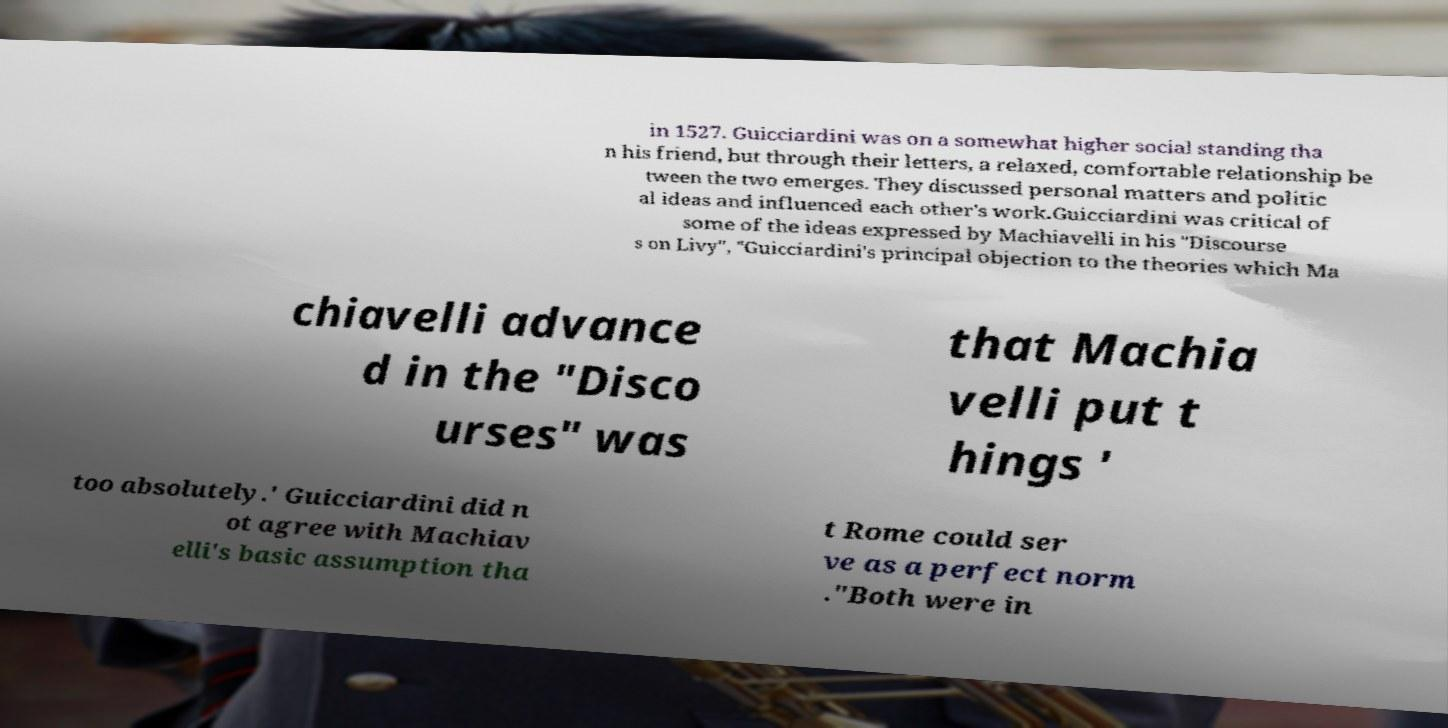What messages or text are displayed in this image? I need them in a readable, typed format. in 1527. Guicciardini was on a somewhat higher social standing tha n his friend, but through their letters, a relaxed, comfortable relationship be tween the two emerges. They discussed personal matters and politic al ideas and influenced each other's work.Guicciardini was critical of some of the ideas expressed by Machiavelli in his "Discourse s on Livy", "Guicciardini's principal objection to the theories which Ma chiavelli advance d in the "Disco urses" was that Machia velli put t hings ' too absolutely.' Guicciardini did n ot agree with Machiav elli's basic assumption tha t Rome could ser ve as a perfect norm ."Both were in 